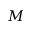Convert formula to latex. <formula><loc_0><loc_0><loc_500><loc_500>M</formula> 